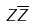Convert formula to latex. <formula><loc_0><loc_0><loc_500><loc_500>Z \overline { Z }</formula> 